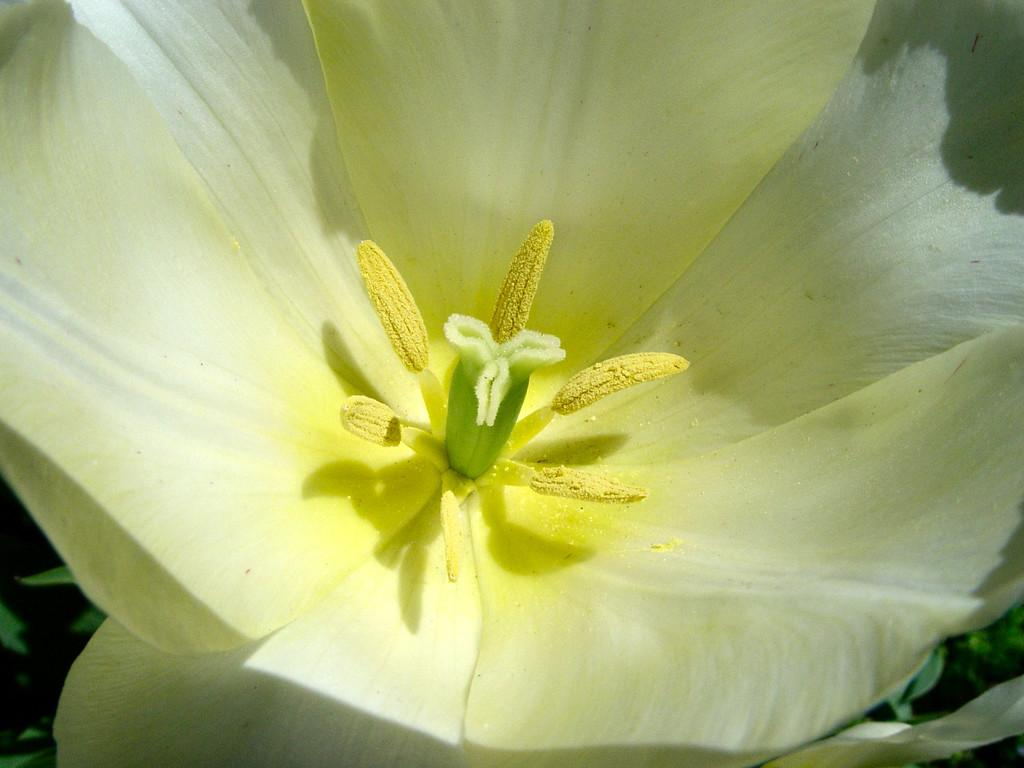What is the main subject of the image? There is a flower in the image. Can you describe the colors of the flower? The flower has yellow, green, and white colors. What else can be seen in the background of the image? There are leaves in the background of the image. What color are the leaves? The leaves are green in color. What type of soda is being poured into the flower in the image? There is no soda present in the image; it features a flower with leaves in the background. What song is being sung by the flower in the image? There is no indication in the image that the flower is singing a song. 